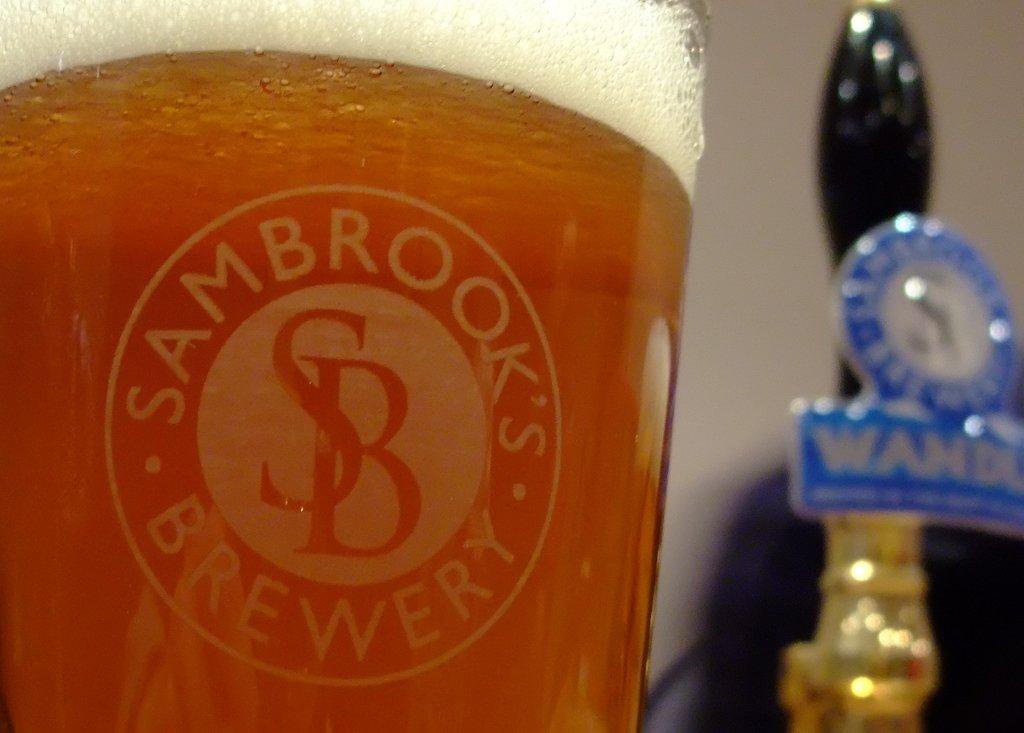What are the first 4 letters on the beer tap?
Give a very brief answer. Wand. 